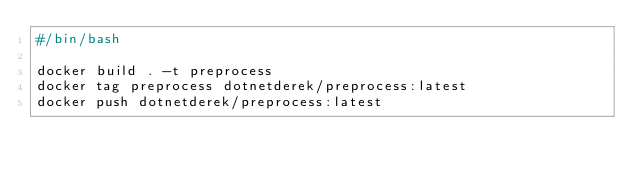Convert code to text. <code><loc_0><loc_0><loc_500><loc_500><_Bash_>#/bin/bash

docker build . -t preprocess
docker tag preprocess dotnetderek/preprocess:latest
docker push dotnetderek/preprocess:latest</code> 